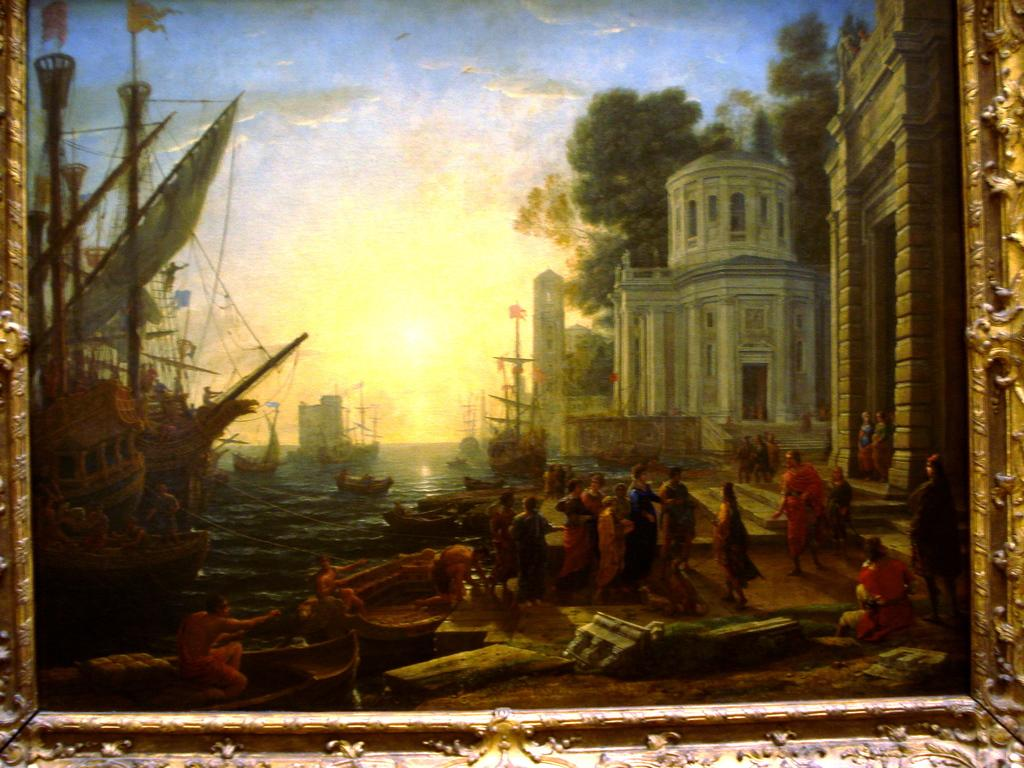What object in the image contains a picture? There is a photo frame in the image that contains a picture of people. What can be seen in the picture within the photo frame? The picture within the photo frame contains boats. What type of natural environment is visible in the image? There is water visible in the image, as well as trees. What type of structures can be seen in the image? There are buildings in the image. What is visible in the sky in the image? The sky is visible in the image, and there are clouds present. How many friends are sitting on the wing of the airplane in the image? There is no airplane or wing present in the image; it features a photo frame with a picture of people and boats. 